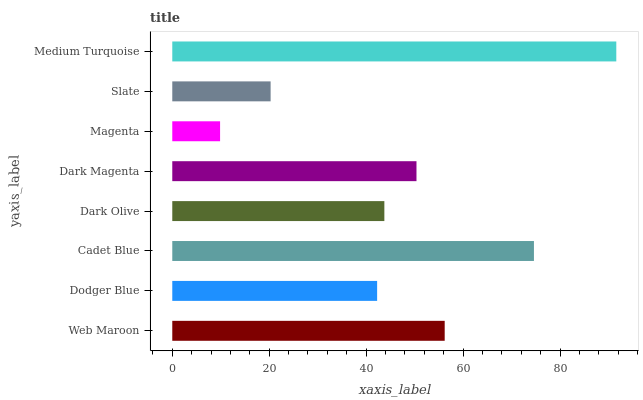Is Magenta the minimum?
Answer yes or no. Yes. Is Medium Turquoise the maximum?
Answer yes or no. Yes. Is Dodger Blue the minimum?
Answer yes or no. No. Is Dodger Blue the maximum?
Answer yes or no. No. Is Web Maroon greater than Dodger Blue?
Answer yes or no. Yes. Is Dodger Blue less than Web Maroon?
Answer yes or no. Yes. Is Dodger Blue greater than Web Maroon?
Answer yes or no. No. Is Web Maroon less than Dodger Blue?
Answer yes or no. No. Is Dark Magenta the high median?
Answer yes or no. Yes. Is Dark Olive the low median?
Answer yes or no. Yes. Is Web Maroon the high median?
Answer yes or no. No. Is Web Maroon the low median?
Answer yes or no. No. 